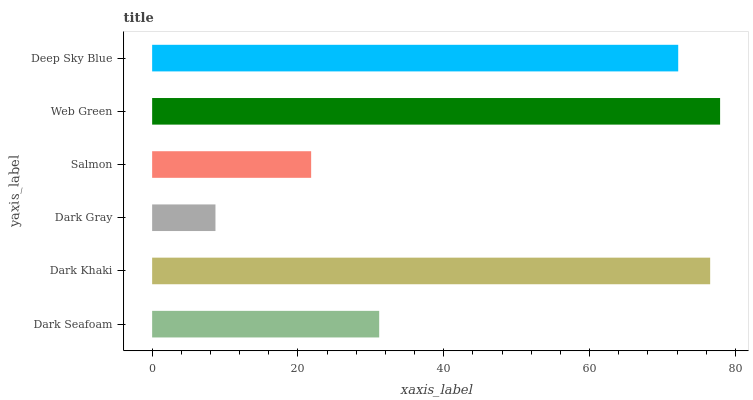Is Dark Gray the minimum?
Answer yes or no. Yes. Is Web Green the maximum?
Answer yes or no. Yes. Is Dark Khaki the minimum?
Answer yes or no. No. Is Dark Khaki the maximum?
Answer yes or no. No. Is Dark Khaki greater than Dark Seafoam?
Answer yes or no. Yes. Is Dark Seafoam less than Dark Khaki?
Answer yes or no. Yes. Is Dark Seafoam greater than Dark Khaki?
Answer yes or no. No. Is Dark Khaki less than Dark Seafoam?
Answer yes or no. No. Is Deep Sky Blue the high median?
Answer yes or no. Yes. Is Dark Seafoam the low median?
Answer yes or no. Yes. Is Web Green the high median?
Answer yes or no. No. Is Dark Gray the low median?
Answer yes or no. No. 